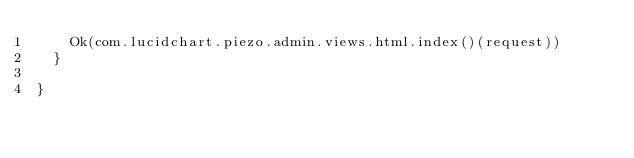Convert code to text. <code><loc_0><loc_0><loc_500><loc_500><_Scala_>    Ok(com.lucidchart.piezo.admin.views.html.index()(request))
  }
  
}</code> 